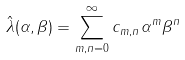Convert formula to latex. <formula><loc_0><loc_0><loc_500><loc_500>\hat { \lambda } ( \alpha , \beta ) = \sum _ { m , n = 0 } ^ { \infty } c _ { m , n } \alpha ^ { m } \beta ^ { n }</formula> 